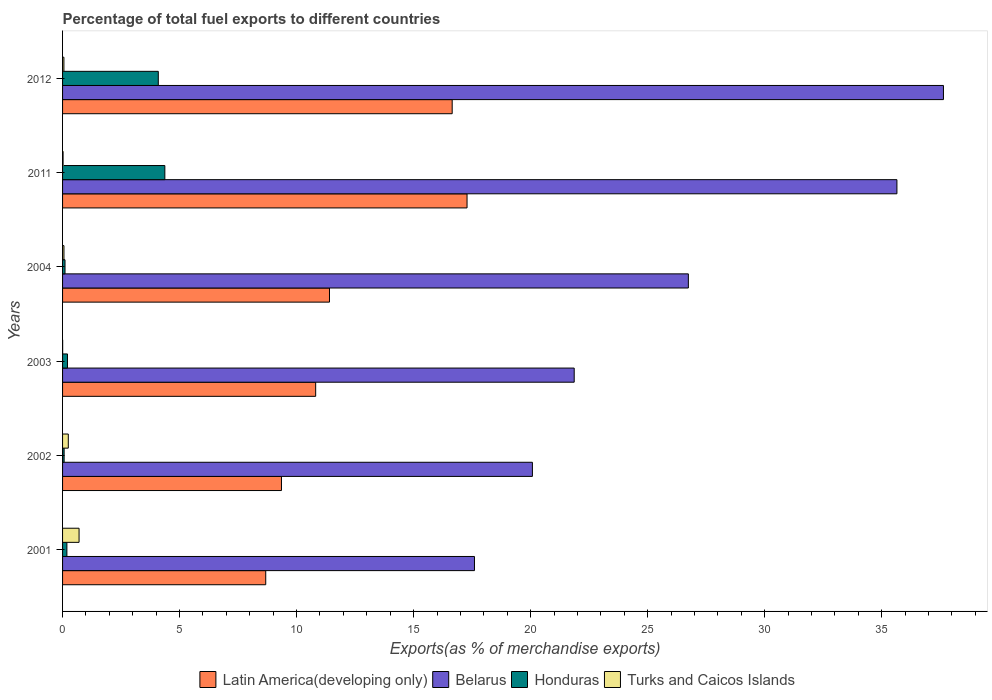How many groups of bars are there?
Your answer should be compact. 6. Are the number of bars per tick equal to the number of legend labels?
Ensure brevity in your answer.  Yes. Are the number of bars on each tick of the Y-axis equal?
Your answer should be compact. Yes. What is the label of the 5th group of bars from the top?
Offer a terse response. 2002. What is the percentage of exports to different countries in Honduras in 2003?
Make the answer very short. 0.21. Across all years, what is the maximum percentage of exports to different countries in Belarus?
Offer a very short reply. 37.64. Across all years, what is the minimum percentage of exports to different countries in Latin America(developing only)?
Give a very brief answer. 8.68. In which year was the percentage of exports to different countries in Honduras maximum?
Provide a short and direct response. 2011. What is the total percentage of exports to different countries in Latin America(developing only) in the graph?
Give a very brief answer. 74.19. What is the difference between the percentage of exports to different countries in Latin America(developing only) in 2003 and that in 2012?
Your answer should be compact. -5.83. What is the difference between the percentage of exports to different countries in Turks and Caicos Islands in 2011 and the percentage of exports to different countries in Honduras in 2001?
Provide a succinct answer. -0.16. What is the average percentage of exports to different countries in Latin America(developing only) per year?
Offer a terse response. 12.36. In the year 2011, what is the difference between the percentage of exports to different countries in Belarus and percentage of exports to different countries in Turks and Caicos Islands?
Offer a terse response. 35.63. What is the ratio of the percentage of exports to different countries in Honduras in 2001 to that in 2012?
Make the answer very short. 0.05. Is the percentage of exports to different countries in Latin America(developing only) in 2001 less than that in 2011?
Offer a terse response. Yes. Is the difference between the percentage of exports to different countries in Belarus in 2001 and 2003 greater than the difference between the percentage of exports to different countries in Turks and Caicos Islands in 2001 and 2003?
Provide a succinct answer. No. What is the difference between the highest and the second highest percentage of exports to different countries in Honduras?
Provide a short and direct response. 0.28. What is the difference between the highest and the lowest percentage of exports to different countries in Honduras?
Offer a very short reply. 4.3. In how many years, is the percentage of exports to different countries in Turks and Caicos Islands greater than the average percentage of exports to different countries in Turks and Caicos Islands taken over all years?
Offer a terse response. 2. Is the sum of the percentage of exports to different countries in Honduras in 2002 and 2011 greater than the maximum percentage of exports to different countries in Belarus across all years?
Make the answer very short. No. What does the 3rd bar from the top in 2011 represents?
Make the answer very short. Belarus. What does the 2nd bar from the bottom in 2012 represents?
Your response must be concise. Belarus. Is it the case that in every year, the sum of the percentage of exports to different countries in Latin America(developing only) and percentage of exports to different countries in Belarus is greater than the percentage of exports to different countries in Turks and Caicos Islands?
Provide a short and direct response. Yes. Are all the bars in the graph horizontal?
Provide a short and direct response. Yes. Are the values on the major ticks of X-axis written in scientific E-notation?
Give a very brief answer. No. Does the graph contain grids?
Make the answer very short. No. Where does the legend appear in the graph?
Your response must be concise. Bottom center. How many legend labels are there?
Offer a terse response. 4. What is the title of the graph?
Ensure brevity in your answer.  Percentage of total fuel exports to different countries. Does "Congo (Democratic)" appear as one of the legend labels in the graph?
Make the answer very short. No. What is the label or title of the X-axis?
Keep it short and to the point. Exports(as % of merchandise exports). What is the label or title of the Y-axis?
Your response must be concise. Years. What is the Exports(as % of merchandise exports) of Latin America(developing only) in 2001?
Provide a succinct answer. 8.68. What is the Exports(as % of merchandise exports) in Belarus in 2001?
Provide a short and direct response. 17.6. What is the Exports(as % of merchandise exports) of Honduras in 2001?
Offer a very short reply. 0.18. What is the Exports(as % of merchandise exports) in Turks and Caicos Islands in 2001?
Provide a short and direct response. 0.7. What is the Exports(as % of merchandise exports) of Latin America(developing only) in 2002?
Your response must be concise. 9.35. What is the Exports(as % of merchandise exports) in Belarus in 2002?
Make the answer very short. 20.08. What is the Exports(as % of merchandise exports) in Honduras in 2002?
Offer a very short reply. 0.07. What is the Exports(as % of merchandise exports) in Turks and Caicos Islands in 2002?
Your answer should be very brief. 0.24. What is the Exports(as % of merchandise exports) in Latin America(developing only) in 2003?
Offer a very short reply. 10.82. What is the Exports(as % of merchandise exports) in Belarus in 2003?
Ensure brevity in your answer.  21.86. What is the Exports(as % of merchandise exports) of Honduras in 2003?
Keep it short and to the point. 0.21. What is the Exports(as % of merchandise exports) in Turks and Caicos Islands in 2003?
Provide a short and direct response. 0. What is the Exports(as % of merchandise exports) of Latin America(developing only) in 2004?
Offer a terse response. 11.41. What is the Exports(as % of merchandise exports) of Belarus in 2004?
Your answer should be compact. 26.74. What is the Exports(as % of merchandise exports) in Honduras in 2004?
Offer a terse response. 0.1. What is the Exports(as % of merchandise exports) in Turks and Caicos Islands in 2004?
Keep it short and to the point. 0.06. What is the Exports(as % of merchandise exports) of Latin America(developing only) in 2011?
Keep it short and to the point. 17.28. What is the Exports(as % of merchandise exports) of Belarus in 2011?
Ensure brevity in your answer.  35.65. What is the Exports(as % of merchandise exports) in Honduras in 2011?
Provide a short and direct response. 4.37. What is the Exports(as % of merchandise exports) in Turks and Caicos Islands in 2011?
Your answer should be very brief. 0.02. What is the Exports(as % of merchandise exports) of Latin America(developing only) in 2012?
Your answer should be very brief. 16.65. What is the Exports(as % of merchandise exports) in Belarus in 2012?
Ensure brevity in your answer.  37.64. What is the Exports(as % of merchandise exports) in Honduras in 2012?
Provide a succinct answer. 4.09. What is the Exports(as % of merchandise exports) in Turks and Caicos Islands in 2012?
Ensure brevity in your answer.  0.06. Across all years, what is the maximum Exports(as % of merchandise exports) of Latin America(developing only)?
Your answer should be very brief. 17.28. Across all years, what is the maximum Exports(as % of merchandise exports) in Belarus?
Ensure brevity in your answer.  37.64. Across all years, what is the maximum Exports(as % of merchandise exports) in Honduras?
Your answer should be very brief. 4.37. Across all years, what is the maximum Exports(as % of merchandise exports) of Turks and Caicos Islands?
Keep it short and to the point. 0.7. Across all years, what is the minimum Exports(as % of merchandise exports) of Latin America(developing only)?
Give a very brief answer. 8.68. Across all years, what is the minimum Exports(as % of merchandise exports) of Belarus?
Give a very brief answer. 17.6. Across all years, what is the minimum Exports(as % of merchandise exports) in Honduras?
Make the answer very short. 0.07. Across all years, what is the minimum Exports(as % of merchandise exports) in Turks and Caicos Islands?
Your response must be concise. 0. What is the total Exports(as % of merchandise exports) in Latin America(developing only) in the graph?
Provide a short and direct response. 74.19. What is the total Exports(as % of merchandise exports) of Belarus in the graph?
Provide a short and direct response. 159.58. What is the total Exports(as % of merchandise exports) of Honduras in the graph?
Make the answer very short. 9.03. What is the total Exports(as % of merchandise exports) in Turks and Caicos Islands in the graph?
Your response must be concise. 1.09. What is the difference between the Exports(as % of merchandise exports) in Latin America(developing only) in 2001 and that in 2002?
Offer a terse response. -0.67. What is the difference between the Exports(as % of merchandise exports) in Belarus in 2001 and that in 2002?
Make the answer very short. -2.48. What is the difference between the Exports(as % of merchandise exports) in Honduras in 2001 and that in 2002?
Your answer should be compact. 0.12. What is the difference between the Exports(as % of merchandise exports) in Turks and Caicos Islands in 2001 and that in 2002?
Make the answer very short. 0.46. What is the difference between the Exports(as % of merchandise exports) of Latin America(developing only) in 2001 and that in 2003?
Offer a terse response. -2.13. What is the difference between the Exports(as % of merchandise exports) of Belarus in 2001 and that in 2003?
Offer a terse response. -4.26. What is the difference between the Exports(as % of merchandise exports) of Honduras in 2001 and that in 2003?
Offer a very short reply. -0.03. What is the difference between the Exports(as % of merchandise exports) in Turks and Caicos Islands in 2001 and that in 2003?
Provide a short and direct response. 0.7. What is the difference between the Exports(as % of merchandise exports) of Latin America(developing only) in 2001 and that in 2004?
Your response must be concise. -2.72. What is the difference between the Exports(as % of merchandise exports) of Belarus in 2001 and that in 2004?
Offer a terse response. -9.14. What is the difference between the Exports(as % of merchandise exports) of Honduras in 2001 and that in 2004?
Make the answer very short. 0.08. What is the difference between the Exports(as % of merchandise exports) in Turks and Caicos Islands in 2001 and that in 2004?
Give a very brief answer. 0.65. What is the difference between the Exports(as % of merchandise exports) in Latin America(developing only) in 2001 and that in 2011?
Keep it short and to the point. -8.6. What is the difference between the Exports(as % of merchandise exports) of Belarus in 2001 and that in 2011?
Give a very brief answer. -18.05. What is the difference between the Exports(as % of merchandise exports) of Honduras in 2001 and that in 2011?
Provide a short and direct response. -4.19. What is the difference between the Exports(as % of merchandise exports) in Turks and Caicos Islands in 2001 and that in 2011?
Your answer should be compact. 0.68. What is the difference between the Exports(as % of merchandise exports) of Latin America(developing only) in 2001 and that in 2012?
Provide a succinct answer. -7.97. What is the difference between the Exports(as % of merchandise exports) in Belarus in 2001 and that in 2012?
Ensure brevity in your answer.  -20.04. What is the difference between the Exports(as % of merchandise exports) of Honduras in 2001 and that in 2012?
Make the answer very short. -3.91. What is the difference between the Exports(as % of merchandise exports) of Turks and Caicos Islands in 2001 and that in 2012?
Your answer should be compact. 0.65. What is the difference between the Exports(as % of merchandise exports) of Latin America(developing only) in 2002 and that in 2003?
Your response must be concise. -1.46. What is the difference between the Exports(as % of merchandise exports) in Belarus in 2002 and that in 2003?
Make the answer very short. -1.79. What is the difference between the Exports(as % of merchandise exports) in Honduras in 2002 and that in 2003?
Offer a terse response. -0.14. What is the difference between the Exports(as % of merchandise exports) of Turks and Caicos Islands in 2002 and that in 2003?
Make the answer very short. 0.24. What is the difference between the Exports(as % of merchandise exports) of Latin America(developing only) in 2002 and that in 2004?
Ensure brevity in your answer.  -2.05. What is the difference between the Exports(as % of merchandise exports) of Belarus in 2002 and that in 2004?
Your response must be concise. -6.66. What is the difference between the Exports(as % of merchandise exports) of Honduras in 2002 and that in 2004?
Your answer should be very brief. -0.04. What is the difference between the Exports(as % of merchandise exports) in Turks and Caicos Islands in 2002 and that in 2004?
Make the answer very short. 0.19. What is the difference between the Exports(as % of merchandise exports) in Latin America(developing only) in 2002 and that in 2011?
Offer a very short reply. -7.93. What is the difference between the Exports(as % of merchandise exports) in Belarus in 2002 and that in 2011?
Your answer should be very brief. -15.58. What is the difference between the Exports(as % of merchandise exports) of Honduras in 2002 and that in 2011?
Your answer should be compact. -4.3. What is the difference between the Exports(as % of merchandise exports) of Turks and Caicos Islands in 2002 and that in 2011?
Ensure brevity in your answer.  0.22. What is the difference between the Exports(as % of merchandise exports) of Latin America(developing only) in 2002 and that in 2012?
Provide a short and direct response. -7.29. What is the difference between the Exports(as % of merchandise exports) in Belarus in 2002 and that in 2012?
Offer a very short reply. -17.56. What is the difference between the Exports(as % of merchandise exports) of Honduras in 2002 and that in 2012?
Give a very brief answer. -4.02. What is the difference between the Exports(as % of merchandise exports) in Turks and Caicos Islands in 2002 and that in 2012?
Offer a terse response. 0.19. What is the difference between the Exports(as % of merchandise exports) in Latin America(developing only) in 2003 and that in 2004?
Offer a very short reply. -0.59. What is the difference between the Exports(as % of merchandise exports) of Belarus in 2003 and that in 2004?
Make the answer very short. -4.88. What is the difference between the Exports(as % of merchandise exports) of Honduras in 2003 and that in 2004?
Provide a succinct answer. 0.11. What is the difference between the Exports(as % of merchandise exports) of Turks and Caicos Islands in 2003 and that in 2004?
Your answer should be very brief. -0.06. What is the difference between the Exports(as % of merchandise exports) in Latin America(developing only) in 2003 and that in 2011?
Your answer should be compact. -6.47. What is the difference between the Exports(as % of merchandise exports) in Belarus in 2003 and that in 2011?
Keep it short and to the point. -13.79. What is the difference between the Exports(as % of merchandise exports) of Honduras in 2003 and that in 2011?
Your answer should be compact. -4.16. What is the difference between the Exports(as % of merchandise exports) of Turks and Caicos Islands in 2003 and that in 2011?
Provide a succinct answer. -0.02. What is the difference between the Exports(as % of merchandise exports) of Latin America(developing only) in 2003 and that in 2012?
Your response must be concise. -5.83. What is the difference between the Exports(as % of merchandise exports) in Belarus in 2003 and that in 2012?
Keep it short and to the point. -15.78. What is the difference between the Exports(as % of merchandise exports) of Honduras in 2003 and that in 2012?
Make the answer very short. -3.88. What is the difference between the Exports(as % of merchandise exports) in Turks and Caicos Islands in 2003 and that in 2012?
Make the answer very short. -0.05. What is the difference between the Exports(as % of merchandise exports) in Latin America(developing only) in 2004 and that in 2011?
Your answer should be compact. -5.88. What is the difference between the Exports(as % of merchandise exports) of Belarus in 2004 and that in 2011?
Ensure brevity in your answer.  -8.91. What is the difference between the Exports(as % of merchandise exports) in Honduras in 2004 and that in 2011?
Your answer should be very brief. -4.27. What is the difference between the Exports(as % of merchandise exports) in Turks and Caicos Islands in 2004 and that in 2011?
Your response must be concise. 0.04. What is the difference between the Exports(as % of merchandise exports) of Latin America(developing only) in 2004 and that in 2012?
Your answer should be very brief. -5.24. What is the difference between the Exports(as % of merchandise exports) of Belarus in 2004 and that in 2012?
Offer a terse response. -10.9. What is the difference between the Exports(as % of merchandise exports) in Honduras in 2004 and that in 2012?
Your response must be concise. -3.99. What is the difference between the Exports(as % of merchandise exports) of Turks and Caicos Islands in 2004 and that in 2012?
Offer a terse response. 0. What is the difference between the Exports(as % of merchandise exports) in Latin America(developing only) in 2011 and that in 2012?
Your answer should be very brief. 0.64. What is the difference between the Exports(as % of merchandise exports) of Belarus in 2011 and that in 2012?
Your answer should be very brief. -1.99. What is the difference between the Exports(as % of merchandise exports) in Honduras in 2011 and that in 2012?
Provide a short and direct response. 0.28. What is the difference between the Exports(as % of merchandise exports) in Turks and Caicos Islands in 2011 and that in 2012?
Give a very brief answer. -0.04. What is the difference between the Exports(as % of merchandise exports) in Latin America(developing only) in 2001 and the Exports(as % of merchandise exports) in Belarus in 2002?
Your answer should be compact. -11.4. What is the difference between the Exports(as % of merchandise exports) in Latin America(developing only) in 2001 and the Exports(as % of merchandise exports) in Honduras in 2002?
Offer a terse response. 8.61. What is the difference between the Exports(as % of merchandise exports) in Latin America(developing only) in 2001 and the Exports(as % of merchandise exports) in Turks and Caicos Islands in 2002?
Give a very brief answer. 8.44. What is the difference between the Exports(as % of merchandise exports) in Belarus in 2001 and the Exports(as % of merchandise exports) in Honduras in 2002?
Provide a succinct answer. 17.53. What is the difference between the Exports(as % of merchandise exports) of Belarus in 2001 and the Exports(as % of merchandise exports) of Turks and Caicos Islands in 2002?
Your response must be concise. 17.36. What is the difference between the Exports(as % of merchandise exports) of Honduras in 2001 and the Exports(as % of merchandise exports) of Turks and Caicos Islands in 2002?
Make the answer very short. -0.06. What is the difference between the Exports(as % of merchandise exports) of Latin America(developing only) in 2001 and the Exports(as % of merchandise exports) of Belarus in 2003?
Provide a short and direct response. -13.18. What is the difference between the Exports(as % of merchandise exports) in Latin America(developing only) in 2001 and the Exports(as % of merchandise exports) in Honduras in 2003?
Keep it short and to the point. 8.47. What is the difference between the Exports(as % of merchandise exports) in Latin America(developing only) in 2001 and the Exports(as % of merchandise exports) in Turks and Caicos Islands in 2003?
Offer a terse response. 8.68. What is the difference between the Exports(as % of merchandise exports) of Belarus in 2001 and the Exports(as % of merchandise exports) of Honduras in 2003?
Offer a very short reply. 17.39. What is the difference between the Exports(as % of merchandise exports) of Belarus in 2001 and the Exports(as % of merchandise exports) of Turks and Caicos Islands in 2003?
Offer a very short reply. 17.6. What is the difference between the Exports(as % of merchandise exports) of Honduras in 2001 and the Exports(as % of merchandise exports) of Turks and Caicos Islands in 2003?
Your response must be concise. 0.18. What is the difference between the Exports(as % of merchandise exports) of Latin America(developing only) in 2001 and the Exports(as % of merchandise exports) of Belarus in 2004?
Keep it short and to the point. -18.06. What is the difference between the Exports(as % of merchandise exports) of Latin America(developing only) in 2001 and the Exports(as % of merchandise exports) of Honduras in 2004?
Offer a very short reply. 8.58. What is the difference between the Exports(as % of merchandise exports) in Latin America(developing only) in 2001 and the Exports(as % of merchandise exports) in Turks and Caicos Islands in 2004?
Make the answer very short. 8.62. What is the difference between the Exports(as % of merchandise exports) of Belarus in 2001 and the Exports(as % of merchandise exports) of Honduras in 2004?
Your answer should be compact. 17.5. What is the difference between the Exports(as % of merchandise exports) in Belarus in 2001 and the Exports(as % of merchandise exports) in Turks and Caicos Islands in 2004?
Provide a succinct answer. 17.54. What is the difference between the Exports(as % of merchandise exports) of Honduras in 2001 and the Exports(as % of merchandise exports) of Turks and Caicos Islands in 2004?
Keep it short and to the point. 0.13. What is the difference between the Exports(as % of merchandise exports) of Latin America(developing only) in 2001 and the Exports(as % of merchandise exports) of Belarus in 2011?
Provide a short and direct response. -26.97. What is the difference between the Exports(as % of merchandise exports) in Latin America(developing only) in 2001 and the Exports(as % of merchandise exports) in Honduras in 2011?
Give a very brief answer. 4.31. What is the difference between the Exports(as % of merchandise exports) of Latin America(developing only) in 2001 and the Exports(as % of merchandise exports) of Turks and Caicos Islands in 2011?
Your answer should be compact. 8.66. What is the difference between the Exports(as % of merchandise exports) of Belarus in 2001 and the Exports(as % of merchandise exports) of Honduras in 2011?
Keep it short and to the point. 13.23. What is the difference between the Exports(as % of merchandise exports) of Belarus in 2001 and the Exports(as % of merchandise exports) of Turks and Caicos Islands in 2011?
Your response must be concise. 17.58. What is the difference between the Exports(as % of merchandise exports) in Honduras in 2001 and the Exports(as % of merchandise exports) in Turks and Caicos Islands in 2011?
Offer a very short reply. 0.16. What is the difference between the Exports(as % of merchandise exports) of Latin America(developing only) in 2001 and the Exports(as % of merchandise exports) of Belarus in 2012?
Make the answer very short. -28.96. What is the difference between the Exports(as % of merchandise exports) in Latin America(developing only) in 2001 and the Exports(as % of merchandise exports) in Honduras in 2012?
Provide a succinct answer. 4.59. What is the difference between the Exports(as % of merchandise exports) in Latin America(developing only) in 2001 and the Exports(as % of merchandise exports) in Turks and Caicos Islands in 2012?
Ensure brevity in your answer.  8.62. What is the difference between the Exports(as % of merchandise exports) in Belarus in 2001 and the Exports(as % of merchandise exports) in Honduras in 2012?
Offer a terse response. 13.51. What is the difference between the Exports(as % of merchandise exports) of Belarus in 2001 and the Exports(as % of merchandise exports) of Turks and Caicos Islands in 2012?
Your response must be concise. 17.54. What is the difference between the Exports(as % of merchandise exports) in Honduras in 2001 and the Exports(as % of merchandise exports) in Turks and Caicos Islands in 2012?
Your answer should be compact. 0.13. What is the difference between the Exports(as % of merchandise exports) of Latin America(developing only) in 2002 and the Exports(as % of merchandise exports) of Belarus in 2003?
Ensure brevity in your answer.  -12.51. What is the difference between the Exports(as % of merchandise exports) in Latin America(developing only) in 2002 and the Exports(as % of merchandise exports) in Honduras in 2003?
Offer a very short reply. 9.14. What is the difference between the Exports(as % of merchandise exports) in Latin America(developing only) in 2002 and the Exports(as % of merchandise exports) in Turks and Caicos Islands in 2003?
Your answer should be very brief. 9.35. What is the difference between the Exports(as % of merchandise exports) in Belarus in 2002 and the Exports(as % of merchandise exports) in Honduras in 2003?
Your response must be concise. 19.87. What is the difference between the Exports(as % of merchandise exports) of Belarus in 2002 and the Exports(as % of merchandise exports) of Turks and Caicos Islands in 2003?
Provide a short and direct response. 20.07. What is the difference between the Exports(as % of merchandise exports) of Honduras in 2002 and the Exports(as % of merchandise exports) of Turks and Caicos Islands in 2003?
Offer a terse response. 0.06. What is the difference between the Exports(as % of merchandise exports) of Latin America(developing only) in 2002 and the Exports(as % of merchandise exports) of Belarus in 2004?
Your answer should be compact. -17.39. What is the difference between the Exports(as % of merchandise exports) in Latin America(developing only) in 2002 and the Exports(as % of merchandise exports) in Honduras in 2004?
Offer a terse response. 9.25. What is the difference between the Exports(as % of merchandise exports) in Latin America(developing only) in 2002 and the Exports(as % of merchandise exports) in Turks and Caicos Islands in 2004?
Your answer should be compact. 9.29. What is the difference between the Exports(as % of merchandise exports) in Belarus in 2002 and the Exports(as % of merchandise exports) in Honduras in 2004?
Your answer should be compact. 19.97. What is the difference between the Exports(as % of merchandise exports) of Belarus in 2002 and the Exports(as % of merchandise exports) of Turks and Caicos Islands in 2004?
Give a very brief answer. 20.02. What is the difference between the Exports(as % of merchandise exports) in Honduras in 2002 and the Exports(as % of merchandise exports) in Turks and Caicos Islands in 2004?
Keep it short and to the point. 0.01. What is the difference between the Exports(as % of merchandise exports) in Latin America(developing only) in 2002 and the Exports(as % of merchandise exports) in Belarus in 2011?
Provide a succinct answer. -26.3. What is the difference between the Exports(as % of merchandise exports) in Latin America(developing only) in 2002 and the Exports(as % of merchandise exports) in Honduras in 2011?
Provide a succinct answer. 4.98. What is the difference between the Exports(as % of merchandise exports) of Latin America(developing only) in 2002 and the Exports(as % of merchandise exports) of Turks and Caicos Islands in 2011?
Give a very brief answer. 9.33. What is the difference between the Exports(as % of merchandise exports) of Belarus in 2002 and the Exports(as % of merchandise exports) of Honduras in 2011?
Make the answer very short. 15.71. What is the difference between the Exports(as % of merchandise exports) in Belarus in 2002 and the Exports(as % of merchandise exports) in Turks and Caicos Islands in 2011?
Your answer should be compact. 20.06. What is the difference between the Exports(as % of merchandise exports) in Honduras in 2002 and the Exports(as % of merchandise exports) in Turks and Caicos Islands in 2011?
Offer a terse response. 0.04. What is the difference between the Exports(as % of merchandise exports) in Latin America(developing only) in 2002 and the Exports(as % of merchandise exports) in Belarus in 2012?
Give a very brief answer. -28.29. What is the difference between the Exports(as % of merchandise exports) in Latin America(developing only) in 2002 and the Exports(as % of merchandise exports) in Honduras in 2012?
Your answer should be compact. 5.26. What is the difference between the Exports(as % of merchandise exports) of Latin America(developing only) in 2002 and the Exports(as % of merchandise exports) of Turks and Caicos Islands in 2012?
Offer a terse response. 9.3. What is the difference between the Exports(as % of merchandise exports) of Belarus in 2002 and the Exports(as % of merchandise exports) of Honduras in 2012?
Provide a succinct answer. 15.99. What is the difference between the Exports(as % of merchandise exports) in Belarus in 2002 and the Exports(as % of merchandise exports) in Turks and Caicos Islands in 2012?
Your answer should be compact. 20.02. What is the difference between the Exports(as % of merchandise exports) of Honduras in 2002 and the Exports(as % of merchandise exports) of Turks and Caicos Islands in 2012?
Offer a very short reply. 0.01. What is the difference between the Exports(as % of merchandise exports) of Latin America(developing only) in 2003 and the Exports(as % of merchandise exports) of Belarus in 2004?
Your answer should be very brief. -15.93. What is the difference between the Exports(as % of merchandise exports) of Latin America(developing only) in 2003 and the Exports(as % of merchandise exports) of Honduras in 2004?
Give a very brief answer. 10.71. What is the difference between the Exports(as % of merchandise exports) in Latin America(developing only) in 2003 and the Exports(as % of merchandise exports) in Turks and Caicos Islands in 2004?
Your answer should be very brief. 10.76. What is the difference between the Exports(as % of merchandise exports) in Belarus in 2003 and the Exports(as % of merchandise exports) in Honduras in 2004?
Provide a succinct answer. 21.76. What is the difference between the Exports(as % of merchandise exports) in Belarus in 2003 and the Exports(as % of merchandise exports) in Turks and Caicos Islands in 2004?
Make the answer very short. 21.8. What is the difference between the Exports(as % of merchandise exports) in Honduras in 2003 and the Exports(as % of merchandise exports) in Turks and Caicos Islands in 2004?
Provide a short and direct response. 0.15. What is the difference between the Exports(as % of merchandise exports) in Latin America(developing only) in 2003 and the Exports(as % of merchandise exports) in Belarus in 2011?
Make the answer very short. -24.84. What is the difference between the Exports(as % of merchandise exports) of Latin America(developing only) in 2003 and the Exports(as % of merchandise exports) of Honduras in 2011?
Give a very brief answer. 6.45. What is the difference between the Exports(as % of merchandise exports) of Latin America(developing only) in 2003 and the Exports(as % of merchandise exports) of Turks and Caicos Islands in 2011?
Offer a terse response. 10.79. What is the difference between the Exports(as % of merchandise exports) in Belarus in 2003 and the Exports(as % of merchandise exports) in Honduras in 2011?
Provide a short and direct response. 17.49. What is the difference between the Exports(as % of merchandise exports) of Belarus in 2003 and the Exports(as % of merchandise exports) of Turks and Caicos Islands in 2011?
Keep it short and to the point. 21.84. What is the difference between the Exports(as % of merchandise exports) of Honduras in 2003 and the Exports(as % of merchandise exports) of Turks and Caicos Islands in 2011?
Offer a terse response. 0.19. What is the difference between the Exports(as % of merchandise exports) in Latin America(developing only) in 2003 and the Exports(as % of merchandise exports) in Belarus in 2012?
Make the answer very short. -26.83. What is the difference between the Exports(as % of merchandise exports) of Latin America(developing only) in 2003 and the Exports(as % of merchandise exports) of Honduras in 2012?
Your response must be concise. 6.73. What is the difference between the Exports(as % of merchandise exports) of Latin America(developing only) in 2003 and the Exports(as % of merchandise exports) of Turks and Caicos Islands in 2012?
Your answer should be very brief. 10.76. What is the difference between the Exports(as % of merchandise exports) in Belarus in 2003 and the Exports(as % of merchandise exports) in Honduras in 2012?
Give a very brief answer. 17.77. What is the difference between the Exports(as % of merchandise exports) in Belarus in 2003 and the Exports(as % of merchandise exports) in Turks and Caicos Islands in 2012?
Ensure brevity in your answer.  21.81. What is the difference between the Exports(as % of merchandise exports) of Honduras in 2003 and the Exports(as % of merchandise exports) of Turks and Caicos Islands in 2012?
Provide a succinct answer. 0.15. What is the difference between the Exports(as % of merchandise exports) of Latin America(developing only) in 2004 and the Exports(as % of merchandise exports) of Belarus in 2011?
Your answer should be compact. -24.25. What is the difference between the Exports(as % of merchandise exports) in Latin America(developing only) in 2004 and the Exports(as % of merchandise exports) in Honduras in 2011?
Keep it short and to the point. 7.04. What is the difference between the Exports(as % of merchandise exports) in Latin America(developing only) in 2004 and the Exports(as % of merchandise exports) in Turks and Caicos Islands in 2011?
Provide a short and direct response. 11.38. What is the difference between the Exports(as % of merchandise exports) in Belarus in 2004 and the Exports(as % of merchandise exports) in Honduras in 2011?
Provide a short and direct response. 22.37. What is the difference between the Exports(as % of merchandise exports) of Belarus in 2004 and the Exports(as % of merchandise exports) of Turks and Caicos Islands in 2011?
Offer a very short reply. 26.72. What is the difference between the Exports(as % of merchandise exports) of Honduras in 2004 and the Exports(as % of merchandise exports) of Turks and Caicos Islands in 2011?
Your answer should be very brief. 0.08. What is the difference between the Exports(as % of merchandise exports) of Latin America(developing only) in 2004 and the Exports(as % of merchandise exports) of Belarus in 2012?
Your answer should be compact. -26.24. What is the difference between the Exports(as % of merchandise exports) in Latin America(developing only) in 2004 and the Exports(as % of merchandise exports) in Honduras in 2012?
Your answer should be compact. 7.31. What is the difference between the Exports(as % of merchandise exports) in Latin America(developing only) in 2004 and the Exports(as % of merchandise exports) in Turks and Caicos Islands in 2012?
Your answer should be very brief. 11.35. What is the difference between the Exports(as % of merchandise exports) in Belarus in 2004 and the Exports(as % of merchandise exports) in Honduras in 2012?
Offer a terse response. 22.65. What is the difference between the Exports(as % of merchandise exports) of Belarus in 2004 and the Exports(as % of merchandise exports) of Turks and Caicos Islands in 2012?
Offer a very short reply. 26.68. What is the difference between the Exports(as % of merchandise exports) in Honduras in 2004 and the Exports(as % of merchandise exports) in Turks and Caicos Islands in 2012?
Provide a short and direct response. 0.05. What is the difference between the Exports(as % of merchandise exports) of Latin America(developing only) in 2011 and the Exports(as % of merchandise exports) of Belarus in 2012?
Your response must be concise. -20.36. What is the difference between the Exports(as % of merchandise exports) of Latin America(developing only) in 2011 and the Exports(as % of merchandise exports) of Honduras in 2012?
Provide a succinct answer. 13.19. What is the difference between the Exports(as % of merchandise exports) in Latin America(developing only) in 2011 and the Exports(as % of merchandise exports) in Turks and Caicos Islands in 2012?
Give a very brief answer. 17.23. What is the difference between the Exports(as % of merchandise exports) in Belarus in 2011 and the Exports(as % of merchandise exports) in Honduras in 2012?
Offer a terse response. 31.56. What is the difference between the Exports(as % of merchandise exports) of Belarus in 2011 and the Exports(as % of merchandise exports) of Turks and Caicos Islands in 2012?
Offer a very short reply. 35.6. What is the difference between the Exports(as % of merchandise exports) of Honduras in 2011 and the Exports(as % of merchandise exports) of Turks and Caicos Islands in 2012?
Your response must be concise. 4.31. What is the average Exports(as % of merchandise exports) in Latin America(developing only) per year?
Ensure brevity in your answer.  12.37. What is the average Exports(as % of merchandise exports) of Belarus per year?
Your answer should be compact. 26.6. What is the average Exports(as % of merchandise exports) of Honduras per year?
Provide a short and direct response. 1.5. What is the average Exports(as % of merchandise exports) in Turks and Caicos Islands per year?
Ensure brevity in your answer.  0.18. In the year 2001, what is the difference between the Exports(as % of merchandise exports) in Latin America(developing only) and Exports(as % of merchandise exports) in Belarus?
Your response must be concise. -8.92. In the year 2001, what is the difference between the Exports(as % of merchandise exports) of Latin America(developing only) and Exports(as % of merchandise exports) of Honduras?
Offer a terse response. 8.5. In the year 2001, what is the difference between the Exports(as % of merchandise exports) in Latin America(developing only) and Exports(as % of merchandise exports) in Turks and Caicos Islands?
Offer a very short reply. 7.98. In the year 2001, what is the difference between the Exports(as % of merchandise exports) in Belarus and Exports(as % of merchandise exports) in Honduras?
Provide a short and direct response. 17.42. In the year 2001, what is the difference between the Exports(as % of merchandise exports) of Belarus and Exports(as % of merchandise exports) of Turks and Caicos Islands?
Your answer should be compact. 16.9. In the year 2001, what is the difference between the Exports(as % of merchandise exports) of Honduras and Exports(as % of merchandise exports) of Turks and Caicos Islands?
Offer a very short reply. -0.52. In the year 2002, what is the difference between the Exports(as % of merchandise exports) in Latin America(developing only) and Exports(as % of merchandise exports) in Belarus?
Provide a succinct answer. -10.72. In the year 2002, what is the difference between the Exports(as % of merchandise exports) of Latin America(developing only) and Exports(as % of merchandise exports) of Honduras?
Offer a very short reply. 9.29. In the year 2002, what is the difference between the Exports(as % of merchandise exports) in Latin America(developing only) and Exports(as % of merchandise exports) in Turks and Caicos Islands?
Give a very brief answer. 9.11. In the year 2002, what is the difference between the Exports(as % of merchandise exports) of Belarus and Exports(as % of merchandise exports) of Honduras?
Your answer should be very brief. 20.01. In the year 2002, what is the difference between the Exports(as % of merchandise exports) of Belarus and Exports(as % of merchandise exports) of Turks and Caicos Islands?
Provide a short and direct response. 19.83. In the year 2002, what is the difference between the Exports(as % of merchandise exports) in Honduras and Exports(as % of merchandise exports) in Turks and Caicos Islands?
Provide a succinct answer. -0.18. In the year 2003, what is the difference between the Exports(as % of merchandise exports) in Latin America(developing only) and Exports(as % of merchandise exports) in Belarus?
Provide a succinct answer. -11.05. In the year 2003, what is the difference between the Exports(as % of merchandise exports) of Latin America(developing only) and Exports(as % of merchandise exports) of Honduras?
Offer a very short reply. 10.61. In the year 2003, what is the difference between the Exports(as % of merchandise exports) of Latin America(developing only) and Exports(as % of merchandise exports) of Turks and Caicos Islands?
Keep it short and to the point. 10.81. In the year 2003, what is the difference between the Exports(as % of merchandise exports) of Belarus and Exports(as % of merchandise exports) of Honduras?
Offer a terse response. 21.65. In the year 2003, what is the difference between the Exports(as % of merchandise exports) in Belarus and Exports(as % of merchandise exports) in Turks and Caicos Islands?
Keep it short and to the point. 21.86. In the year 2003, what is the difference between the Exports(as % of merchandise exports) of Honduras and Exports(as % of merchandise exports) of Turks and Caicos Islands?
Keep it short and to the point. 0.21. In the year 2004, what is the difference between the Exports(as % of merchandise exports) of Latin America(developing only) and Exports(as % of merchandise exports) of Belarus?
Offer a very short reply. -15.34. In the year 2004, what is the difference between the Exports(as % of merchandise exports) of Latin America(developing only) and Exports(as % of merchandise exports) of Honduras?
Offer a very short reply. 11.3. In the year 2004, what is the difference between the Exports(as % of merchandise exports) in Latin America(developing only) and Exports(as % of merchandise exports) in Turks and Caicos Islands?
Give a very brief answer. 11.35. In the year 2004, what is the difference between the Exports(as % of merchandise exports) in Belarus and Exports(as % of merchandise exports) in Honduras?
Provide a succinct answer. 26.64. In the year 2004, what is the difference between the Exports(as % of merchandise exports) of Belarus and Exports(as % of merchandise exports) of Turks and Caicos Islands?
Your answer should be compact. 26.68. In the year 2004, what is the difference between the Exports(as % of merchandise exports) of Honduras and Exports(as % of merchandise exports) of Turks and Caicos Islands?
Offer a very short reply. 0.05. In the year 2011, what is the difference between the Exports(as % of merchandise exports) of Latin America(developing only) and Exports(as % of merchandise exports) of Belarus?
Provide a short and direct response. -18.37. In the year 2011, what is the difference between the Exports(as % of merchandise exports) in Latin America(developing only) and Exports(as % of merchandise exports) in Honduras?
Your answer should be very brief. 12.91. In the year 2011, what is the difference between the Exports(as % of merchandise exports) in Latin America(developing only) and Exports(as % of merchandise exports) in Turks and Caicos Islands?
Provide a succinct answer. 17.26. In the year 2011, what is the difference between the Exports(as % of merchandise exports) of Belarus and Exports(as % of merchandise exports) of Honduras?
Make the answer very short. 31.28. In the year 2011, what is the difference between the Exports(as % of merchandise exports) of Belarus and Exports(as % of merchandise exports) of Turks and Caicos Islands?
Your response must be concise. 35.63. In the year 2011, what is the difference between the Exports(as % of merchandise exports) of Honduras and Exports(as % of merchandise exports) of Turks and Caicos Islands?
Provide a succinct answer. 4.35. In the year 2012, what is the difference between the Exports(as % of merchandise exports) of Latin America(developing only) and Exports(as % of merchandise exports) of Belarus?
Offer a terse response. -20.99. In the year 2012, what is the difference between the Exports(as % of merchandise exports) of Latin America(developing only) and Exports(as % of merchandise exports) of Honduras?
Offer a very short reply. 12.56. In the year 2012, what is the difference between the Exports(as % of merchandise exports) of Latin America(developing only) and Exports(as % of merchandise exports) of Turks and Caicos Islands?
Your answer should be very brief. 16.59. In the year 2012, what is the difference between the Exports(as % of merchandise exports) of Belarus and Exports(as % of merchandise exports) of Honduras?
Keep it short and to the point. 33.55. In the year 2012, what is the difference between the Exports(as % of merchandise exports) of Belarus and Exports(as % of merchandise exports) of Turks and Caicos Islands?
Offer a very short reply. 37.58. In the year 2012, what is the difference between the Exports(as % of merchandise exports) of Honduras and Exports(as % of merchandise exports) of Turks and Caicos Islands?
Provide a succinct answer. 4.03. What is the ratio of the Exports(as % of merchandise exports) of Latin America(developing only) in 2001 to that in 2002?
Keep it short and to the point. 0.93. What is the ratio of the Exports(as % of merchandise exports) of Belarus in 2001 to that in 2002?
Provide a short and direct response. 0.88. What is the ratio of the Exports(as % of merchandise exports) in Honduras in 2001 to that in 2002?
Keep it short and to the point. 2.77. What is the ratio of the Exports(as % of merchandise exports) of Turks and Caicos Islands in 2001 to that in 2002?
Make the answer very short. 2.88. What is the ratio of the Exports(as % of merchandise exports) of Latin America(developing only) in 2001 to that in 2003?
Offer a very short reply. 0.8. What is the ratio of the Exports(as % of merchandise exports) of Belarus in 2001 to that in 2003?
Offer a terse response. 0.81. What is the ratio of the Exports(as % of merchandise exports) of Honduras in 2001 to that in 2003?
Ensure brevity in your answer.  0.88. What is the ratio of the Exports(as % of merchandise exports) of Turks and Caicos Islands in 2001 to that in 2003?
Ensure brevity in your answer.  236.85. What is the ratio of the Exports(as % of merchandise exports) of Latin America(developing only) in 2001 to that in 2004?
Your answer should be compact. 0.76. What is the ratio of the Exports(as % of merchandise exports) of Belarus in 2001 to that in 2004?
Give a very brief answer. 0.66. What is the ratio of the Exports(as % of merchandise exports) of Honduras in 2001 to that in 2004?
Offer a very short reply. 1.77. What is the ratio of the Exports(as % of merchandise exports) of Turks and Caicos Islands in 2001 to that in 2004?
Keep it short and to the point. 11.94. What is the ratio of the Exports(as % of merchandise exports) of Latin America(developing only) in 2001 to that in 2011?
Your response must be concise. 0.5. What is the ratio of the Exports(as % of merchandise exports) in Belarus in 2001 to that in 2011?
Offer a terse response. 0.49. What is the ratio of the Exports(as % of merchandise exports) of Honduras in 2001 to that in 2011?
Keep it short and to the point. 0.04. What is the ratio of the Exports(as % of merchandise exports) in Turks and Caicos Islands in 2001 to that in 2011?
Give a very brief answer. 32.32. What is the ratio of the Exports(as % of merchandise exports) of Latin America(developing only) in 2001 to that in 2012?
Make the answer very short. 0.52. What is the ratio of the Exports(as % of merchandise exports) of Belarus in 2001 to that in 2012?
Offer a terse response. 0.47. What is the ratio of the Exports(as % of merchandise exports) of Honduras in 2001 to that in 2012?
Your response must be concise. 0.05. What is the ratio of the Exports(as % of merchandise exports) of Turks and Caicos Islands in 2001 to that in 2012?
Ensure brevity in your answer.  12.37. What is the ratio of the Exports(as % of merchandise exports) of Latin America(developing only) in 2002 to that in 2003?
Your answer should be very brief. 0.86. What is the ratio of the Exports(as % of merchandise exports) in Belarus in 2002 to that in 2003?
Offer a terse response. 0.92. What is the ratio of the Exports(as % of merchandise exports) in Honduras in 2002 to that in 2003?
Provide a short and direct response. 0.32. What is the ratio of the Exports(as % of merchandise exports) of Turks and Caicos Islands in 2002 to that in 2003?
Offer a terse response. 82.32. What is the ratio of the Exports(as % of merchandise exports) of Latin America(developing only) in 2002 to that in 2004?
Give a very brief answer. 0.82. What is the ratio of the Exports(as % of merchandise exports) in Belarus in 2002 to that in 2004?
Your answer should be compact. 0.75. What is the ratio of the Exports(as % of merchandise exports) of Honduras in 2002 to that in 2004?
Make the answer very short. 0.64. What is the ratio of the Exports(as % of merchandise exports) of Turks and Caicos Islands in 2002 to that in 2004?
Your response must be concise. 4.15. What is the ratio of the Exports(as % of merchandise exports) in Latin America(developing only) in 2002 to that in 2011?
Offer a terse response. 0.54. What is the ratio of the Exports(as % of merchandise exports) in Belarus in 2002 to that in 2011?
Your answer should be compact. 0.56. What is the ratio of the Exports(as % of merchandise exports) of Honduras in 2002 to that in 2011?
Your response must be concise. 0.02. What is the ratio of the Exports(as % of merchandise exports) in Turks and Caicos Islands in 2002 to that in 2011?
Your answer should be very brief. 11.23. What is the ratio of the Exports(as % of merchandise exports) of Latin America(developing only) in 2002 to that in 2012?
Your answer should be very brief. 0.56. What is the ratio of the Exports(as % of merchandise exports) of Belarus in 2002 to that in 2012?
Your answer should be compact. 0.53. What is the ratio of the Exports(as % of merchandise exports) of Honduras in 2002 to that in 2012?
Your answer should be compact. 0.02. What is the ratio of the Exports(as % of merchandise exports) of Turks and Caicos Islands in 2002 to that in 2012?
Your response must be concise. 4.3. What is the ratio of the Exports(as % of merchandise exports) of Latin America(developing only) in 2003 to that in 2004?
Give a very brief answer. 0.95. What is the ratio of the Exports(as % of merchandise exports) in Belarus in 2003 to that in 2004?
Give a very brief answer. 0.82. What is the ratio of the Exports(as % of merchandise exports) of Honduras in 2003 to that in 2004?
Your response must be concise. 2.01. What is the ratio of the Exports(as % of merchandise exports) in Turks and Caicos Islands in 2003 to that in 2004?
Give a very brief answer. 0.05. What is the ratio of the Exports(as % of merchandise exports) of Latin America(developing only) in 2003 to that in 2011?
Offer a terse response. 0.63. What is the ratio of the Exports(as % of merchandise exports) of Belarus in 2003 to that in 2011?
Keep it short and to the point. 0.61. What is the ratio of the Exports(as % of merchandise exports) in Honduras in 2003 to that in 2011?
Provide a short and direct response. 0.05. What is the ratio of the Exports(as % of merchandise exports) in Turks and Caicos Islands in 2003 to that in 2011?
Keep it short and to the point. 0.14. What is the ratio of the Exports(as % of merchandise exports) in Latin America(developing only) in 2003 to that in 2012?
Provide a succinct answer. 0.65. What is the ratio of the Exports(as % of merchandise exports) in Belarus in 2003 to that in 2012?
Offer a terse response. 0.58. What is the ratio of the Exports(as % of merchandise exports) of Honduras in 2003 to that in 2012?
Ensure brevity in your answer.  0.05. What is the ratio of the Exports(as % of merchandise exports) in Turks and Caicos Islands in 2003 to that in 2012?
Your response must be concise. 0.05. What is the ratio of the Exports(as % of merchandise exports) of Latin America(developing only) in 2004 to that in 2011?
Offer a terse response. 0.66. What is the ratio of the Exports(as % of merchandise exports) in Belarus in 2004 to that in 2011?
Provide a short and direct response. 0.75. What is the ratio of the Exports(as % of merchandise exports) in Honduras in 2004 to that in 2011?
Offer a terse response. 0.02. What is the ratio of the Exports(as % of merchandise exports) in Turks and Caicos Islands in 2004 to that in 2011?
Your answer should be very brief. 2.71. What is the ratio of the Exports(as % of merchandise exports) of Latin America(developing only) in 2004 to that in 2012?
Offer a very short reply. 0.69. What is the ratio of the Exports(as % of merchandise exports) in Belarus in 2004 to that in 2012?
Give a very brief answer. 0.71. What is the ratio of the Exports(as % of merchandise exports) of Honduras in 2004 to that in 2012?
Make the answer very short. 0.03. What is the ratio of the Exports(as % of merchandise exports) of Turks and Caicos Islands in 2004 to that in 2012?
Your answer should be compact. 1.04. What is the ratio of the Exports(as % of merchandise exports) in Latin America(developing only) in 2011 to that in 2012?
Offer a terse response. 1.04. What is the ratio of the Exports(as % of merchandise exports) in Belarus in 2011 to that in 2012?
Give a very brief answer. 0.95. What is the ratio of the Exports(as % of merchandise exports) in Honduras in 2011 to that in 2012?
Provide a succinct answer. 1.07. What is the ratio of the Exports(as % of merchandise exports) in Turks and Caicos Islands in 2011 to that in 2012?
Your answer should be compact. 0.38. What is the difference between the highest and the second highest Exports(as % of merchandise exports) in Latin America(developing only)?
Ensure brevity in your answer.  0.64. What is the difference between the highest and the second highest Exports(as % of merchandise exports) of Belarus?
Offer a very short reply. 1.99. What is the difference between the highest and the second highest Exports(as % of merchandise exports) in Honduras?
Provide a short and direct response. 0.28. What is the difference between the highest and the second highest Exports(as % of merchandise exports) in Turks and Caicos Islands?
Ensure brevity in your answer.  0.46. What is the difference between the highest and the lowest Exports(as % of merchandise exports) in Latin America(developing only)?
Your answer should be compact. 8.6. What is the difference between the highest and the lowest Exports(as % of merchandise exports) of Belarus?
Ensure brevity in your answer.  20.04. What is the difference between the highest and the lowest Exports(as % of merchandise exports) of Honduras?
Your answer should be compact. 4.3. What is the difference between the highest and the lowest Exports(as % of merchandise exports) of Turks and Caicos Islands?
Your response must be concise. 0.7. 